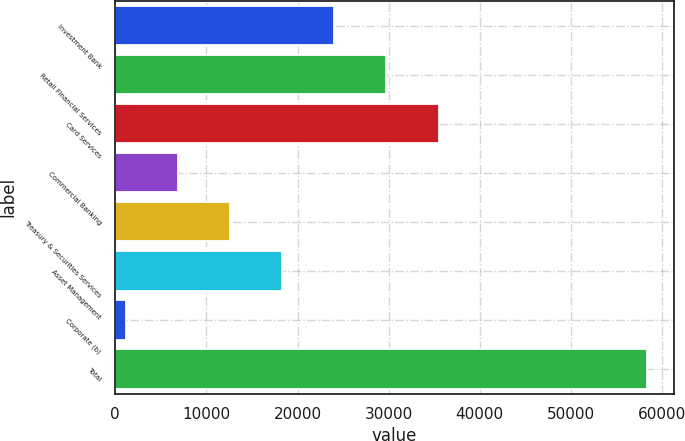Convert chart. <chart><loc_0><loc_0><loc_500><loc_500><bar_chart><fcel>Investment Bank<fcel>Retail Financial Services<fcel>Card Services<fcel>Commercial Banking<fcel>Treasury & Securities Services<fcel>Asset Management<fcel>Corporate (b)<fcel>Total<nl><fcel>24027.2<fcel>29750<fcel>35472.8<fcel>6858.8<fcel>12581.6<fcel>18304.4<fcel>1136<fcel>58364<nl></chart> 